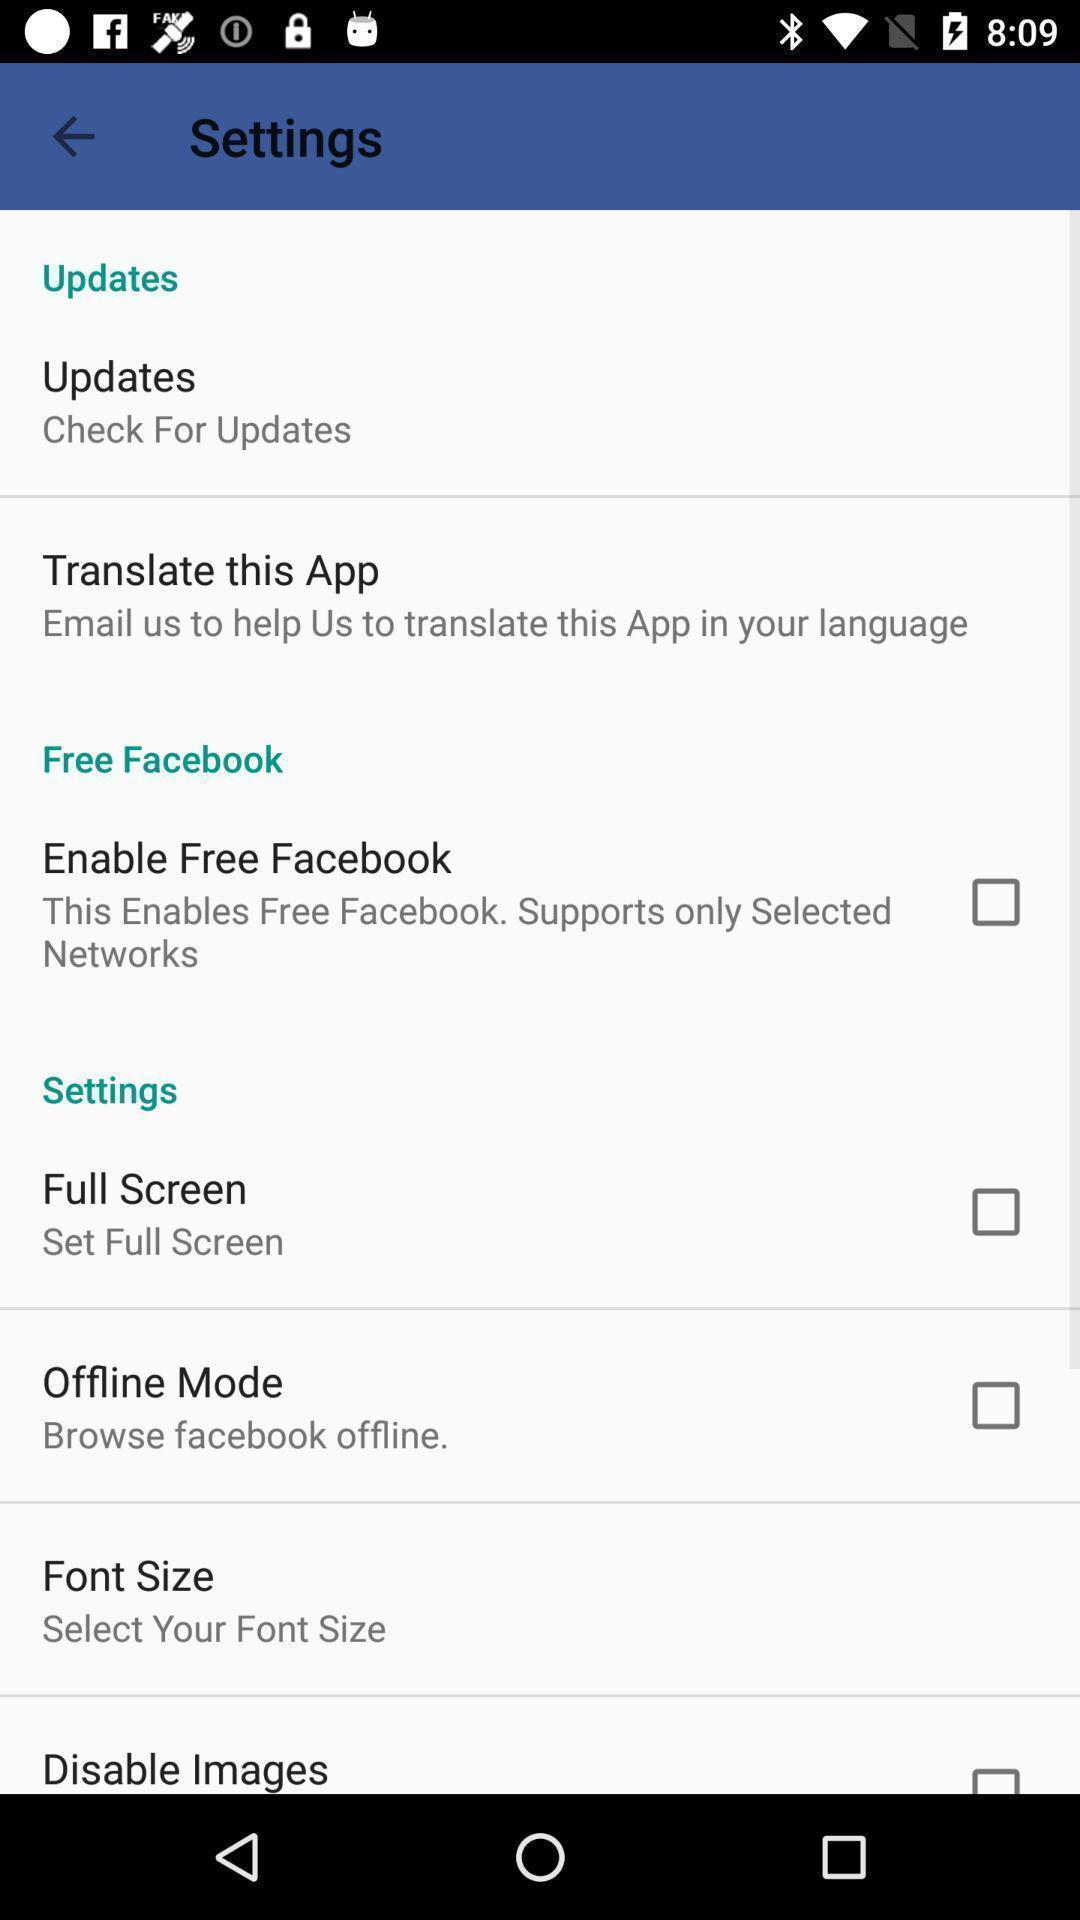Provide a textual representation of this image. Settings page. 